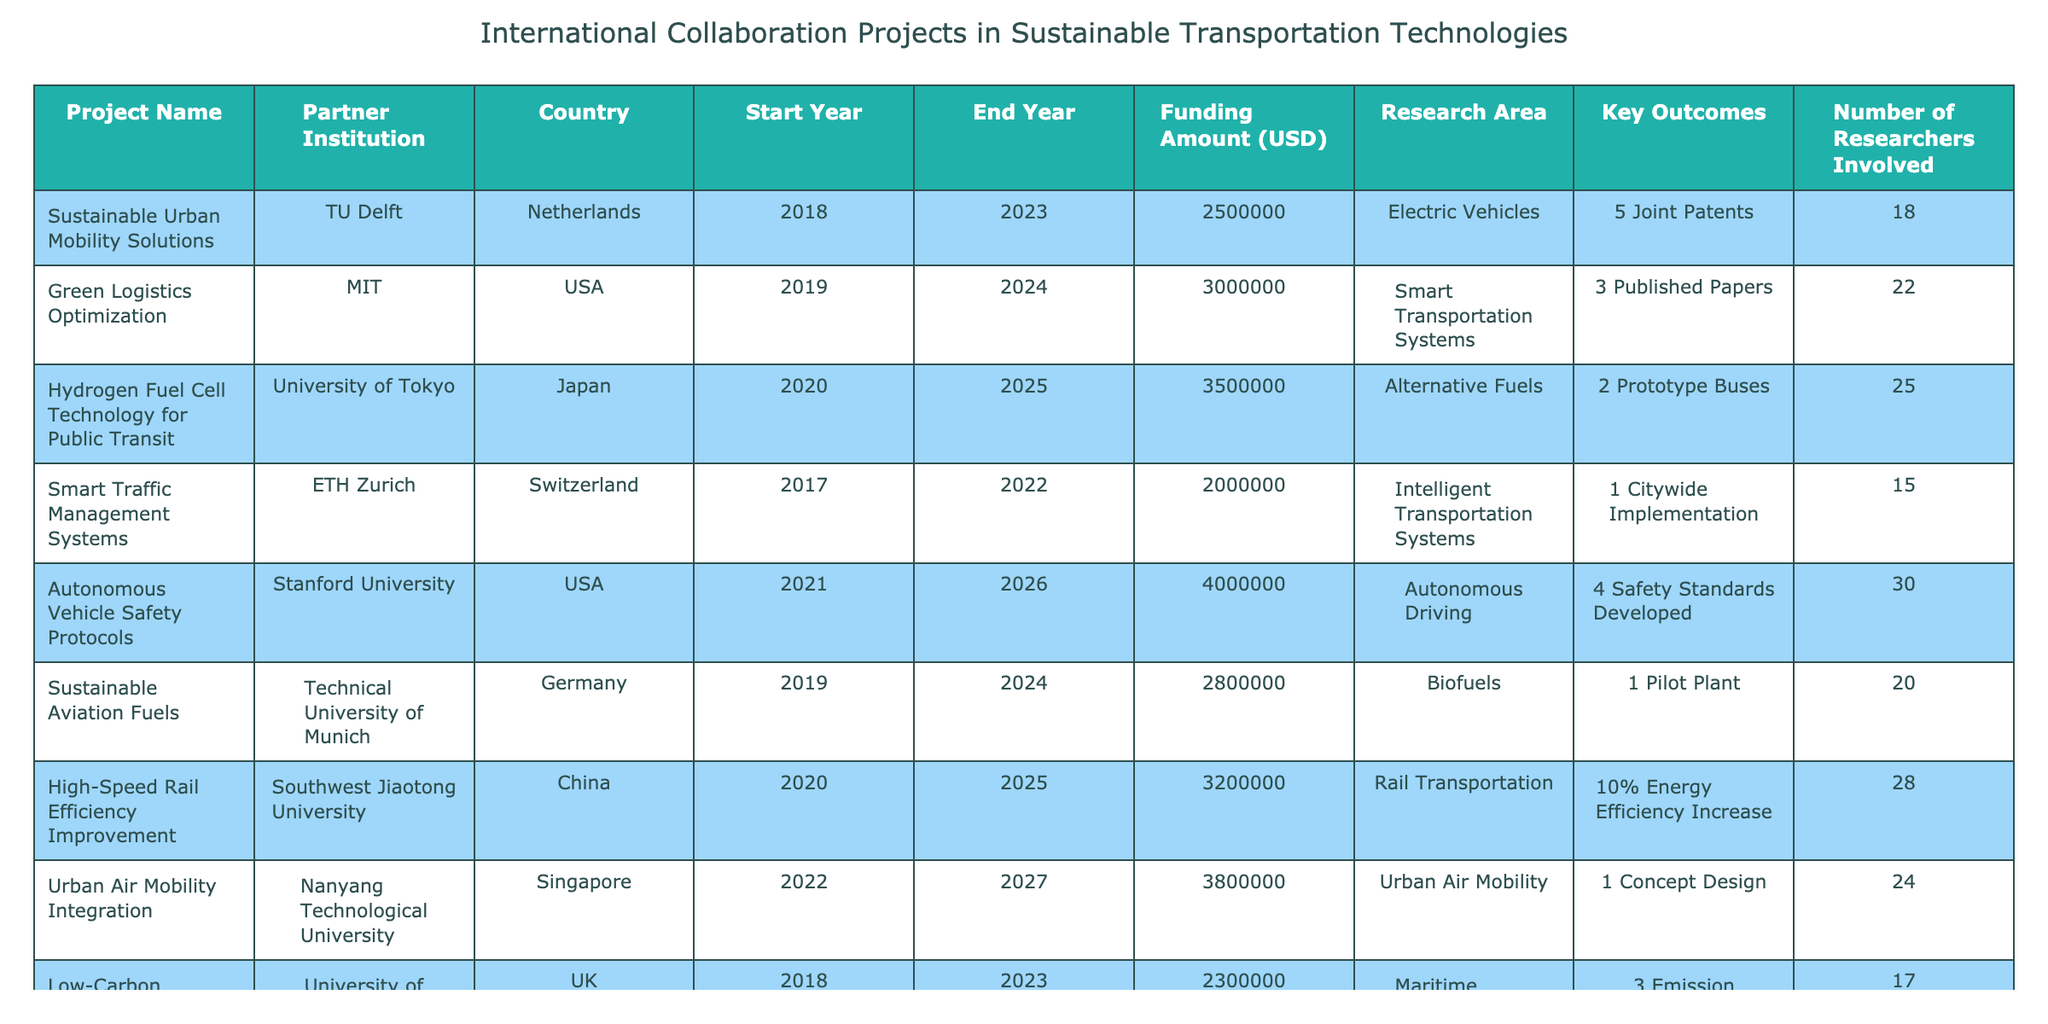What is the total funding amount for collaboration projects involving Tongji University? The individual funding amounts from the table are: 2500000, 3000000, 3500000, 2000000, 4000000, 2800000, 3200000, 3800000, 2300000, and 2700000. Summing these gives a total of 2500000 + 3000000 + 3500000 + 2000000 + 4000000 + 2800000 + 3200000 + 3800000 + 2300000 + 2700000 =  30,000,000.
Answer: 30000000 Which project has the highest number of researchers involved? The projects along with their researchers are: 18, 22, 25, 15, 30, 20, 28, 24, 17, and 21. The highest number is 30, from the Autonomous Vehicle Safety Protocols project.
Answer: Autonomous Vehicle Safety Protocols Did any project have a funding amount of over $3,500,000? Reviewing the funding amounts listed in the table, the amounts are: 2500000, 3000000, 3500000, 2000000, 4000000, 2800000, 3200000, 3800000, 2300000, and 2700000. The funding amount of 4000000 is over 3500000, while others do not exceed that threshold.
Answer: Yes What is the average funding amount across all projects? The funding amounts are: 2500000, 3000000, 3500000, 2000000, 4000000, 2800000, 3200000, 3800000, 2300000, and 2700000. The total is 30000000, and there are 10 projects, so the average is 30000000/10 = 3000000.
Answer: 3000000 Which projects were conducted in the year 2021? The list of projects and their start years includes: Autonomous Vehicle Safety Protocols (2021), Sustainable Last-Mile Delivery Solutions (2021). Both projects started in 2021.
Answer: Autonomous Vehicle Safety Protocols and Sustainable Last-Mile Delivery Solutions If all projects end in 2025 or later, how many partners are involved? The projects ending in 2025 or beyond are: Hydrogen Fuel Cell Technology for Public Transit (2025), Autonomous Vehicle Safety Protocols (2026), Urban Air Mobility Integration (2027), and Sustainable Last-Mile Delivery Solutions (2026). This results in 4 unique partner institutions involved.
Answer: 4 What is the total number of patents developed across all projects? The key outcomes for patents are: 5 from Sustainable Urban Mobility Solutions, 3 from Green Logistics Optimization, 2 from Hydrogen Fuel Cell Technology for Public Transit, 1 from Smart Traffic Management Systems, 4 from Autonomous Vehicle Safety Protocols, and no patents mentioned from others. Summing these yields 5 + 3 + 2 + 1 + 4 = 15 patents.
Answer: 15 Which country has the most collaborations listed? By examining the table, the USA has 2 collaborations (with MIT and Stanford University), while all other countries have 1 collaboration each. Thus, the USA has the most collaborations listed.
Answer: USA What percentage of projects focused on Electric Vehicles compared to the total? The only project focusing on Electric Vehicles is Sustainable Urban Mobility Solutions. There are 10 projects in total, so the percentage is (1/10) * 100 = 10%.
Answer: 10% Which project identified the greatest key outcome in terms of prototypes? The key outcomes include 2 Prototype Buses from the Hydrogen Fuel Cell Technology for Public Transit project. There are no other projects mentioned that produced more than 2 prototypes.
Answer: Hydrogen Fuel Cell Technology for Public Transit 